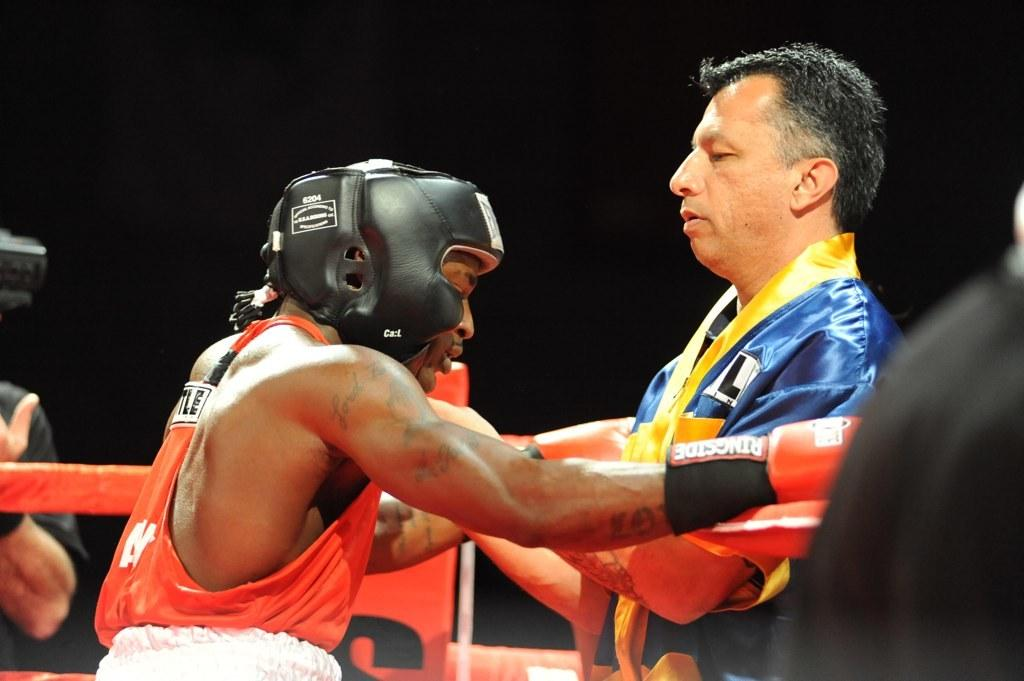How many people are in the image? There are two persons standing in the middle of the image. What is located behind the persons? There is fencing behind the persons. Can you describe anything that is visible behind the fencing? A hand is visible behind the fencing. What type of structure is the stick leaning against in the image? There is no stick or structure present in the image. 